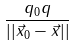<formula> <loc_0><loc_0><loc_500><loc_500>\frac { q _ { 0 } q } { | | \vec { x } _ { 0 } - \vec { x } | | }</formula> 